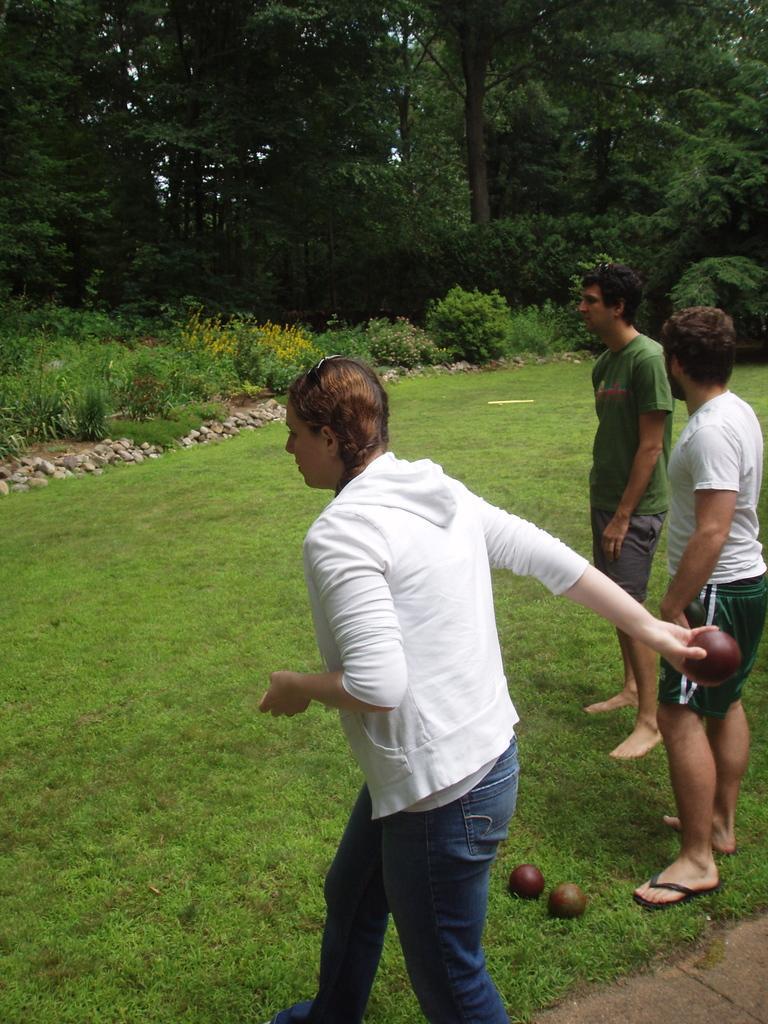In one or two sentences, can you explain what this image depicts? In this image there are three persons visible on the ground, a woman may be holding a ball, on the ground there may be two balls visible, at the top there are some trees, in the middle there are some bushes and plants visible. 